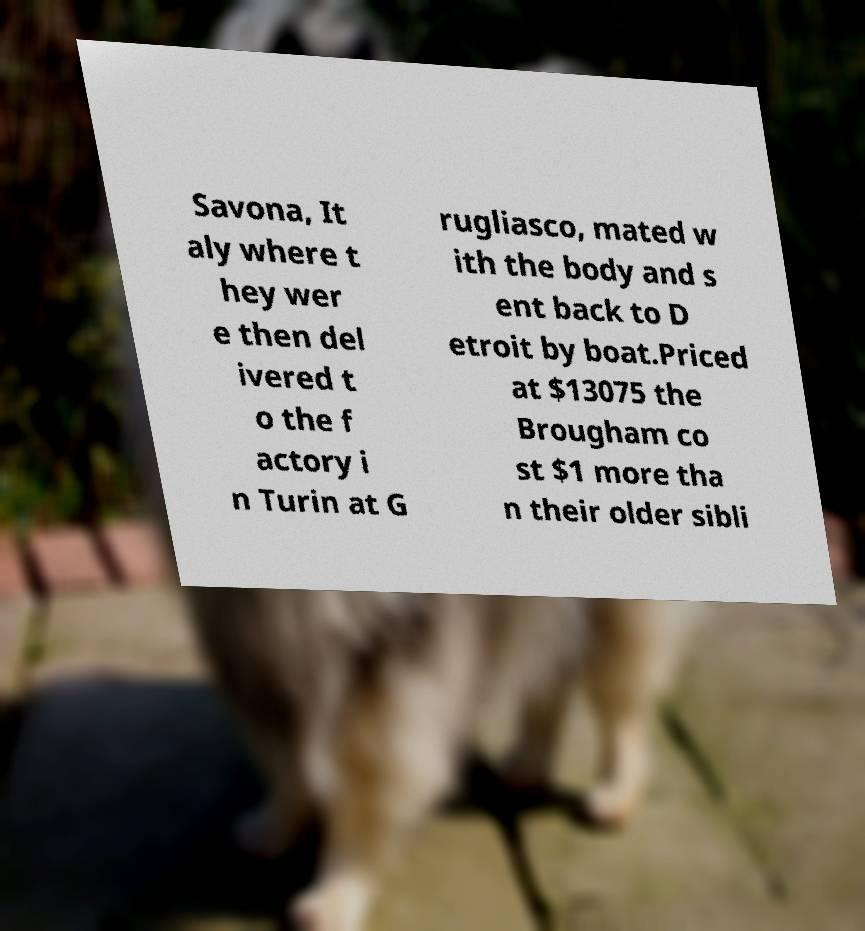There's text embedded in this image that I need extracted. Can you transcribe it verbatim? Savona, It aly where t hey wer e then del ivered t o the f actory i n Turin at G rugliasco, mated w ith the body and s ent back to D etroit by boat.Priced at $13075 the Brougham co st $1 more tha n their older sibli 